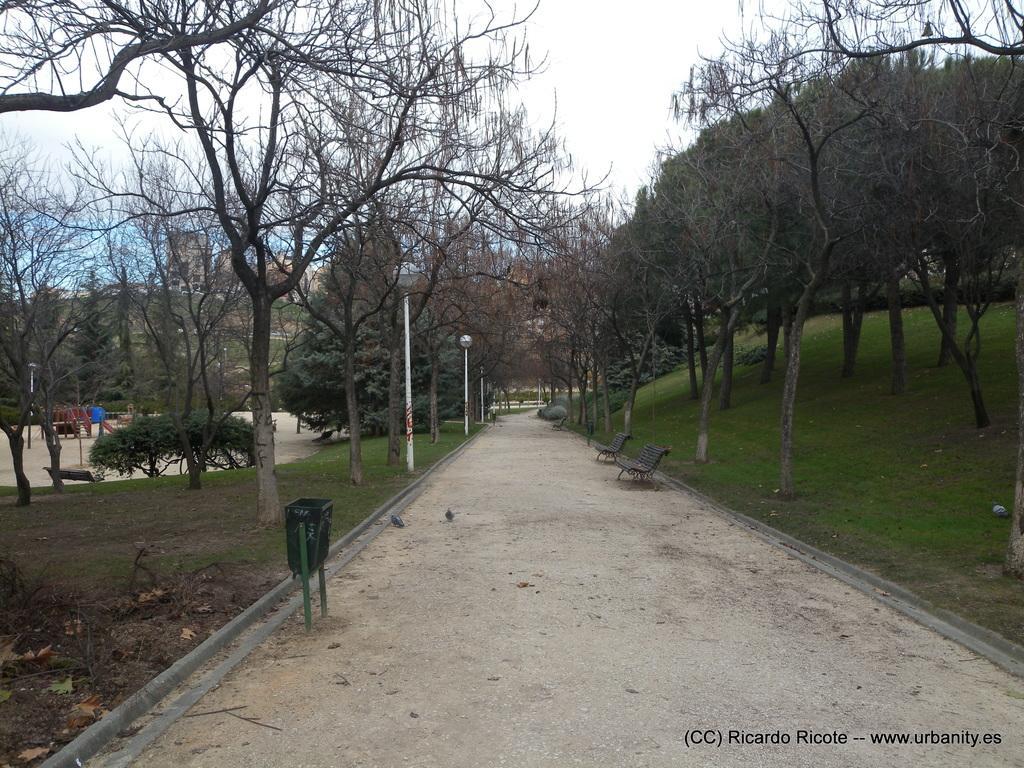Describe this image in one or two sentences. This picture is clicked outside. On the right we can see the benches and some other objects and we can see the lights attached to the poles. On both the sides we can see the green grass and the trees. In the background we can see the sky and some other objects. In the bottom right corner we can see the text on the image. 